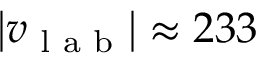<formula> <loc_0><loc_0><loc_500><loc_500>\left | v _ { l a b } \right | \approx 2 3 3</formula> 